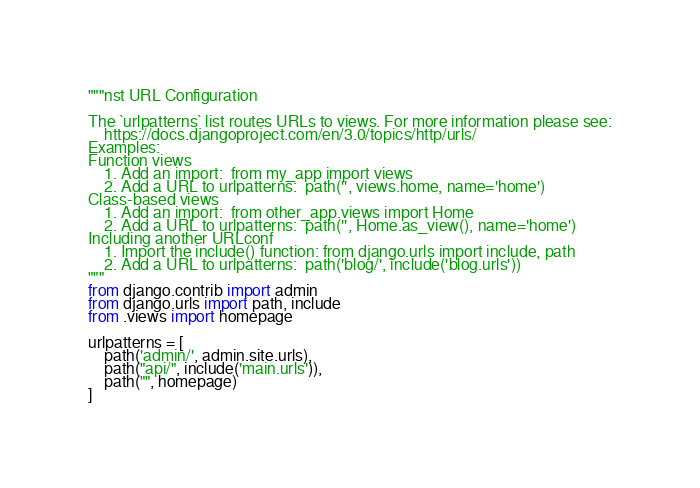Convert code to text. <code><loc_0><loc_0><loc_500><loc_500><_Python_>"""nst URL Configuration

The `urlpatterns` list routes URLs to views. For more information please see:
    https://docs.djangoproject.com/en/3.0/topics/http/urls/
Examples:
Function views
    1. Add an import:  from my_app import views
    2. Add a URL to urlpatterns:  path('', views.home, name='home')
Class-based views
    1. Add an import:  from other_app.views import Home
    2. Add a URL to urlpatterns:  path('', Home.as_view(), name='home')
Including another URLconf
    1. Import the include() function: from django.urls import include, path
    2. Add a URL to urlpatterns:  path('blog/', include('blog.urls'))
"""
from django.contrib import admin
from django.urls import path, include
from .views import homepage

urlpatterns = [
    path('admin/', admin.site.urls),
    path("api/", include('main.urls')),
    path("", homepage)
]</code> 